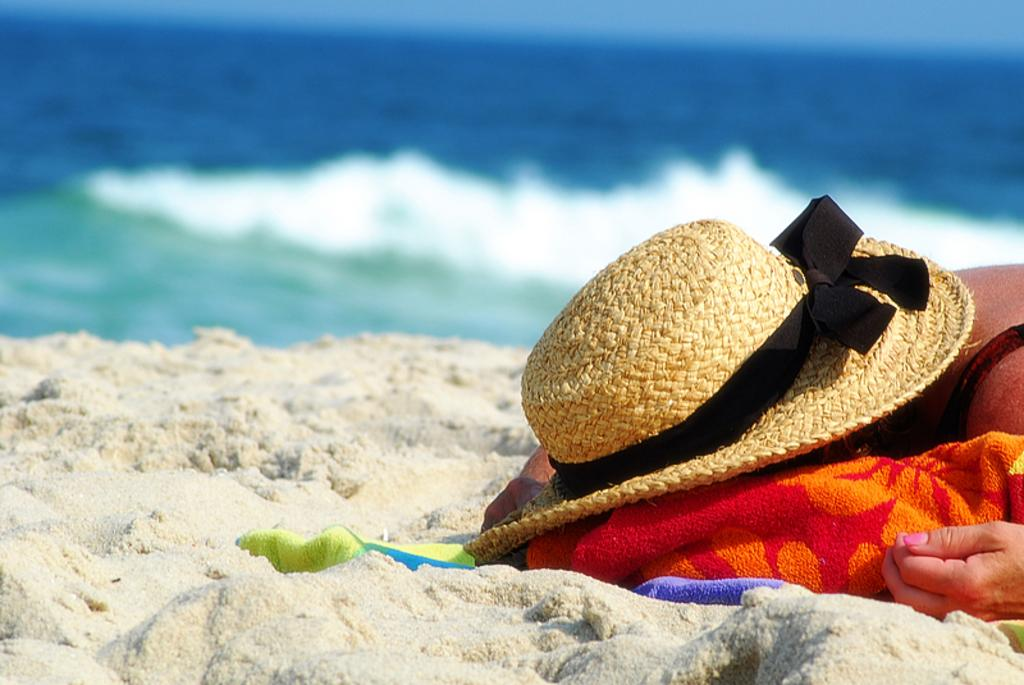What is the person in the image wearing on their head? The person in the image is wearing a hat. What is on the sand in the image? There is a cloth on the sand in the image. What can be seen in the background of the image? There is water visible in the background of the image. What type of riddle is the person in the image trying to solve? There is no indication in the image that the person is trying to solve a riddle. 